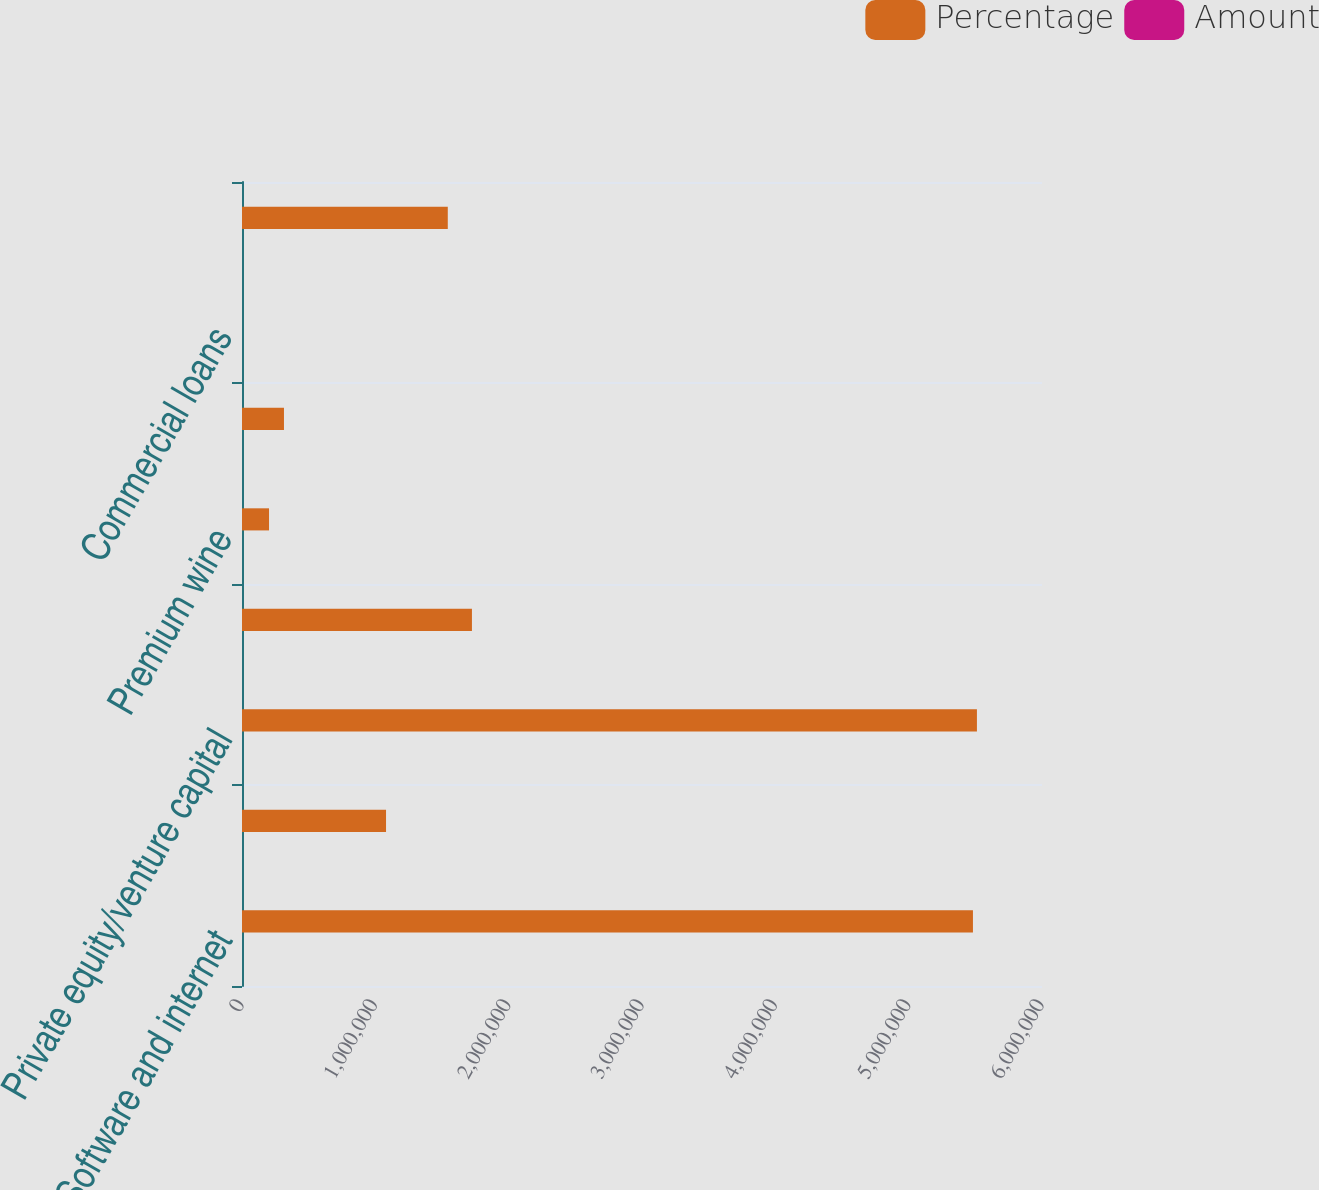Convert chart to OTSL. <chart><loc_0><loc_0><loc_500><loc_500><stacked_bar_chart><ecel><fcel>Software and internet<fcel>Hardware<fcel>Private equity/venture capital<fcel>Life science/healthcare<fcel>Premium wine<fcel>Other<fcel>Commercial loans<fcel>Consumer loans<nl><fcel>Percentage<fcel>5.48211e+06<fcel>1.08023e+06<fcel>5.51193e+06<fcel>1.72454e+06<fcel>202808<fcel>314813<fcel>84.9<fcel>1.54334e+06<nl><fcel>Amount<fcel>32.5<fcel>6.4<fcel>32.7<fcel>10.2<fcel>1.2<fcel>1.9<fcel>84.9<fcel>9.2<nl></chart> 